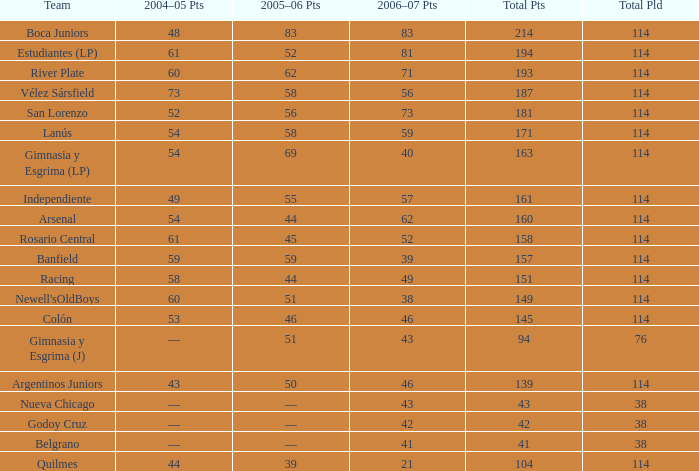What is the typical aggregate pld with 45 points in 2005-06, and in excess of 52 points in 2006-07? None. 